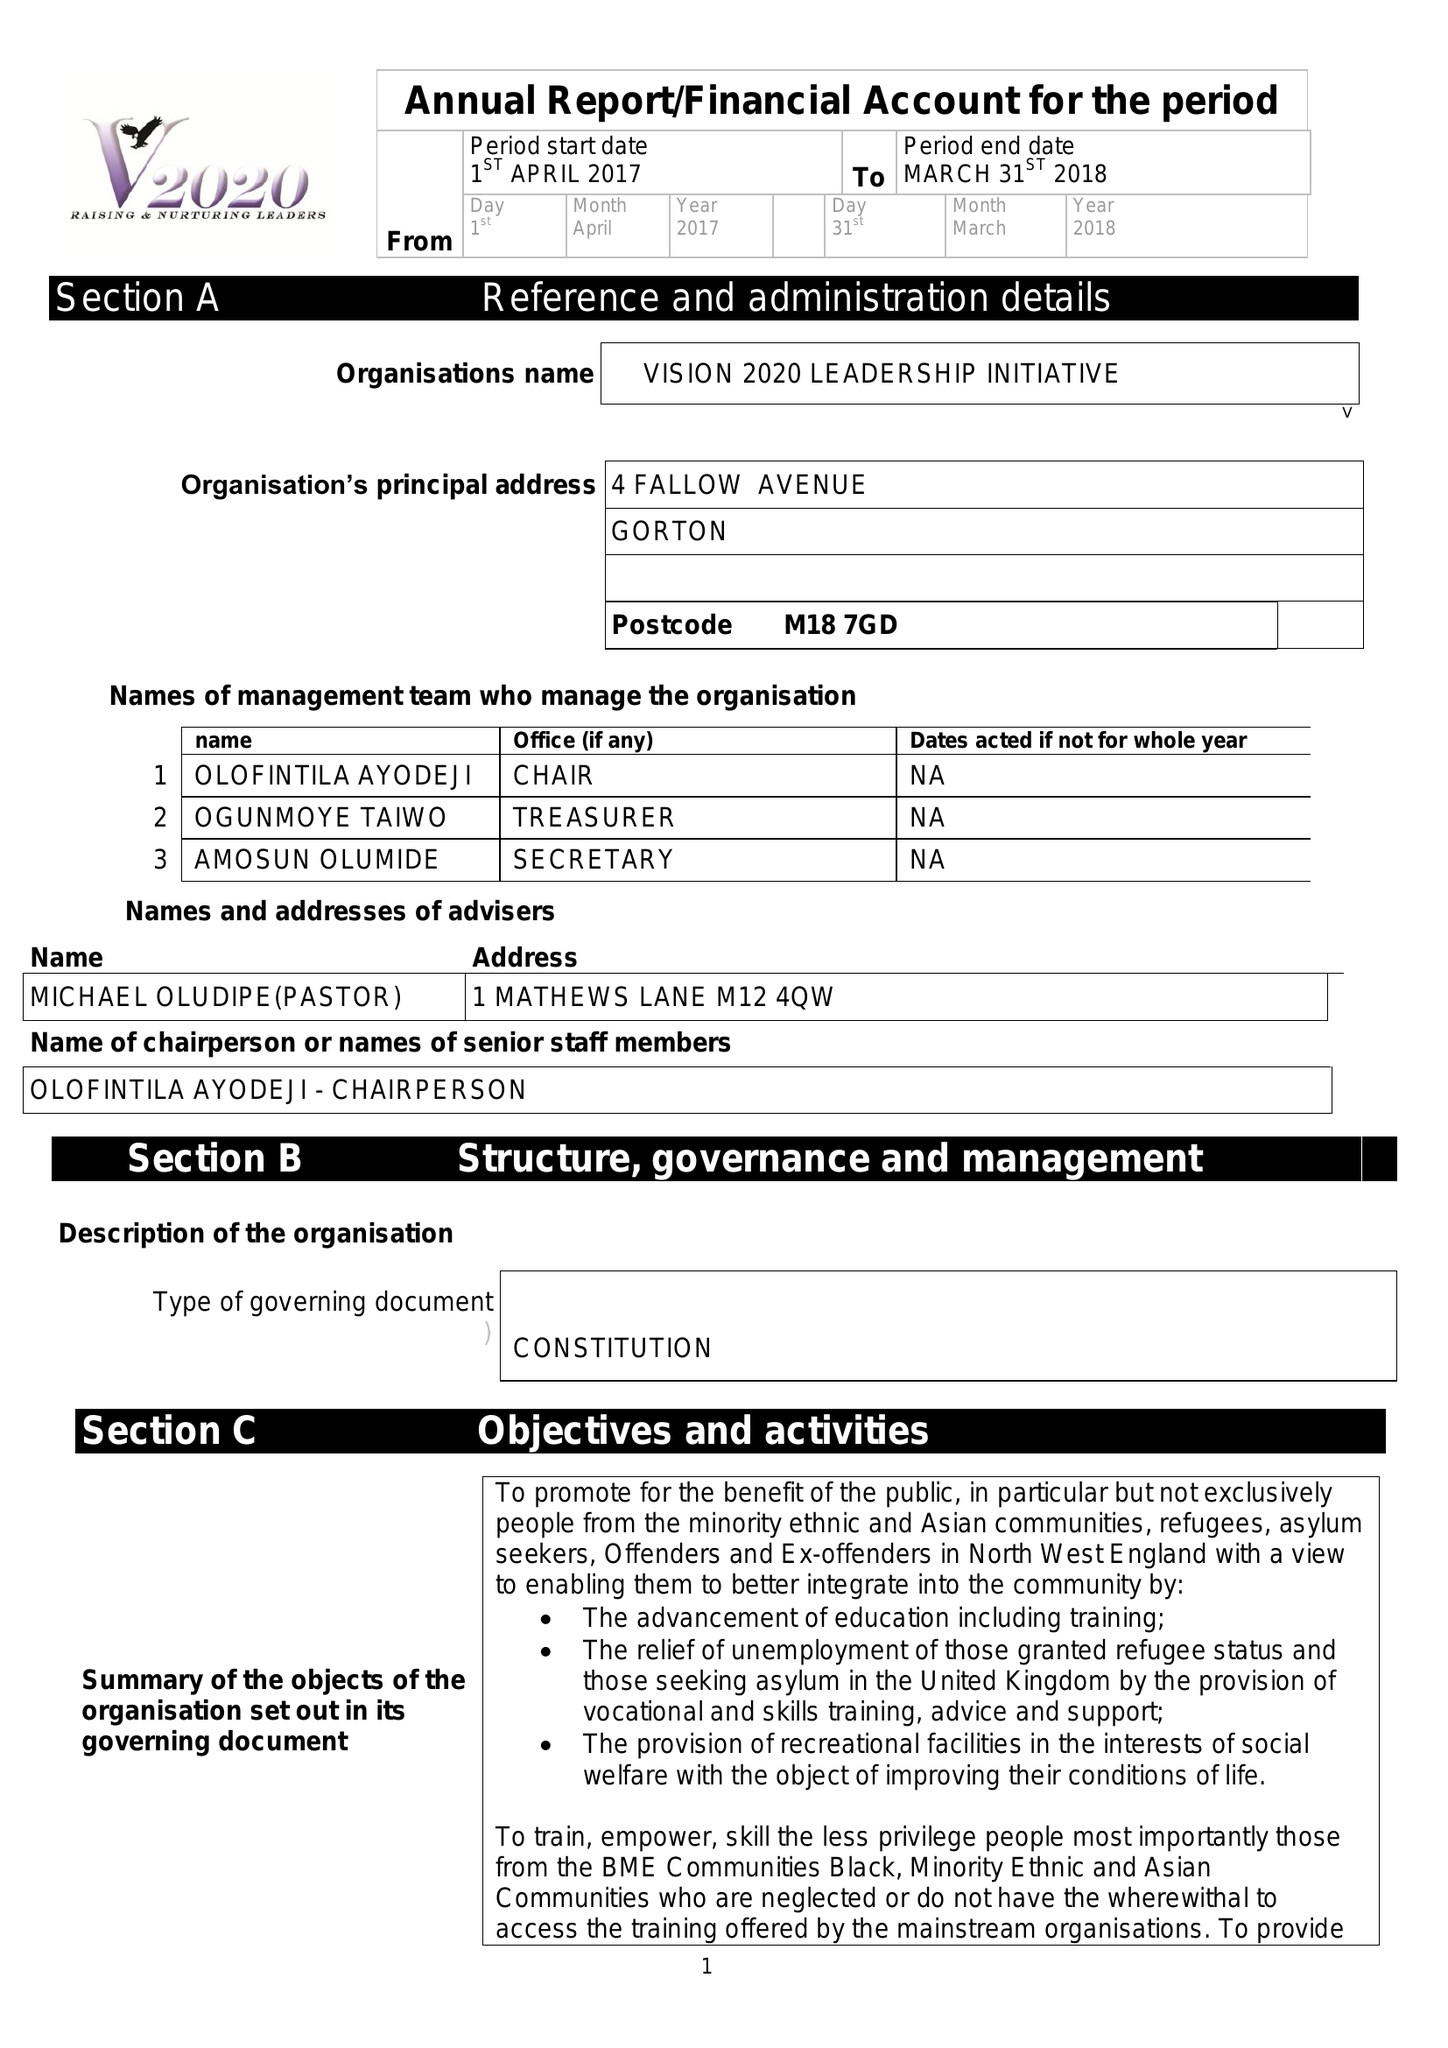What is the value for the report_date?
Answer the question using a single word or phrase. 2018-03-31 